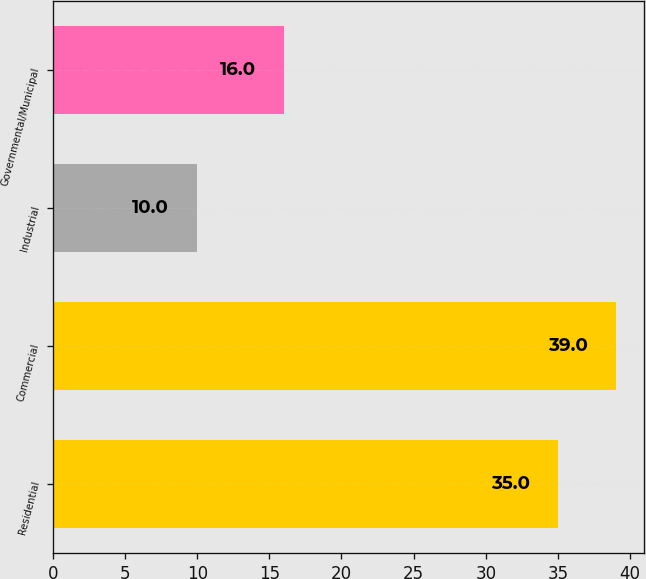<chart> <loc_0><loc_0><loc_500><loc_500><bar_chart><fcel>Residential<fcel>Commercial<fcel>Industrial<fcel>Governmental/Municipal<nl><fcel>35<fcel>39<fcel>10<fcel>16<nl></chart> 